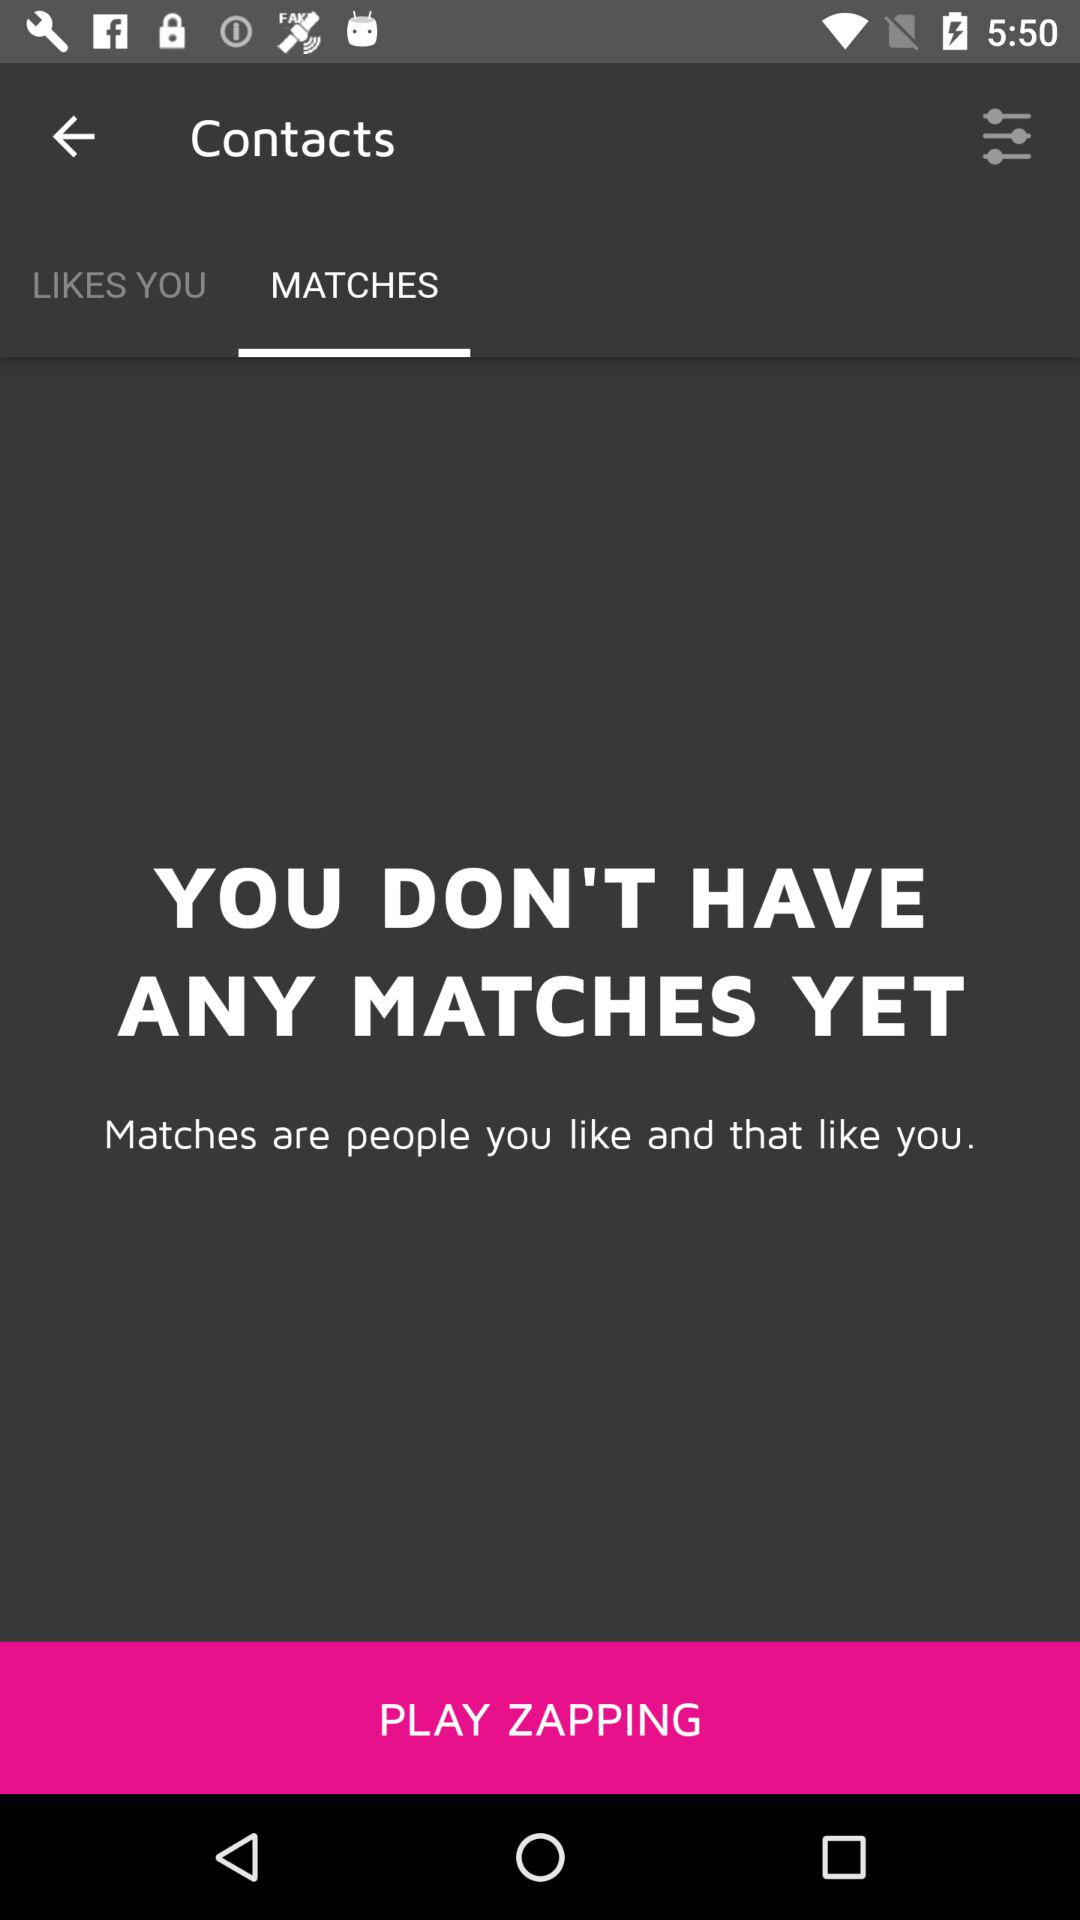What is the application name?
When the provided information is insufficient, respond with <no answer>. <no answer> 